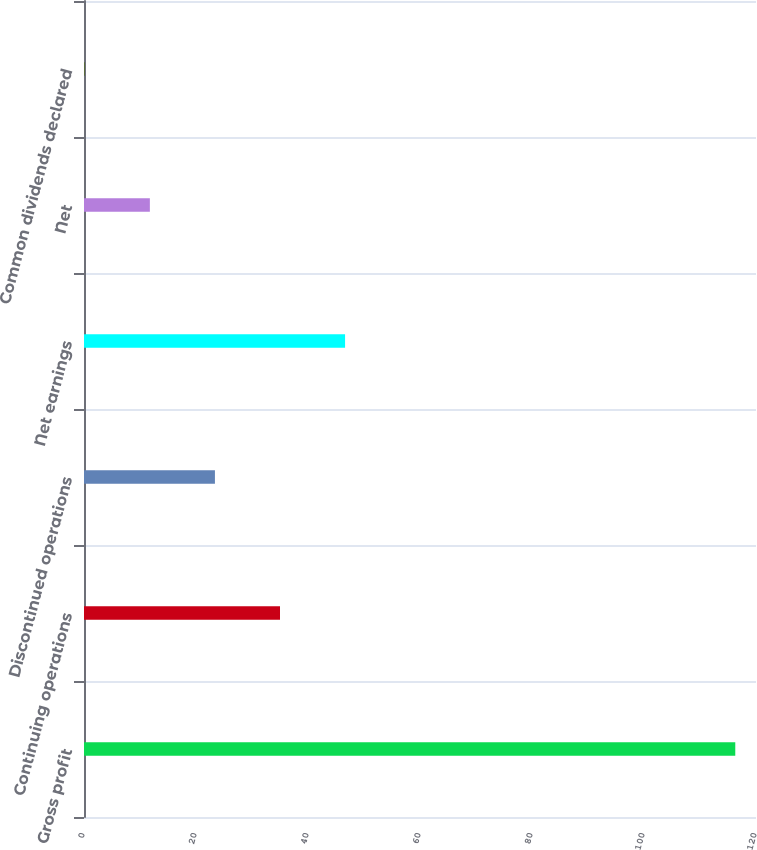Convert chart to OTSL. <chart><loc_0><loc_0><loc_500><loc_500><bar_chart><fcel>Gross profit<fcel>Continuing operations<fcel>Discontinued operations<fcel>Net earnings<fcel>Net<fcel>Common dividends declared<nl><fcel>116.3<fcel>35<fcel>23.38<fcel>46.62<fcel>11.76<fcel>0.14<nl></chart> 